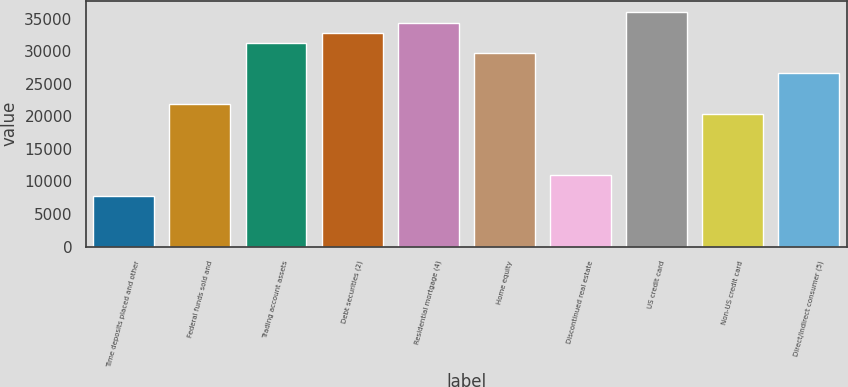Convert chart to OTSL. <chart><loc_0><loc_0><loc_500><loc_500><bar_chart><fcel>Time deposits placed and other<fcel>Federal funds sold and<fcel>Trading account assets<fcel>Debt securities (2)<fcel>Residential mortgage (4)<fcel>Home equity<fcel>Discontinued real estate<fcel>US credit card<fcel>Non-US credit card<fcel>Direct/Indirect consumer (5)<nl><fcel>7818<fcel>21888.6<fcel>31269<fcel>32832.4<fcel>34395.8<fcel>29705.6<fcel>10944.8<fcel>35959.2<fcel>20325.2<fcel>26578.8<nl></chart> 